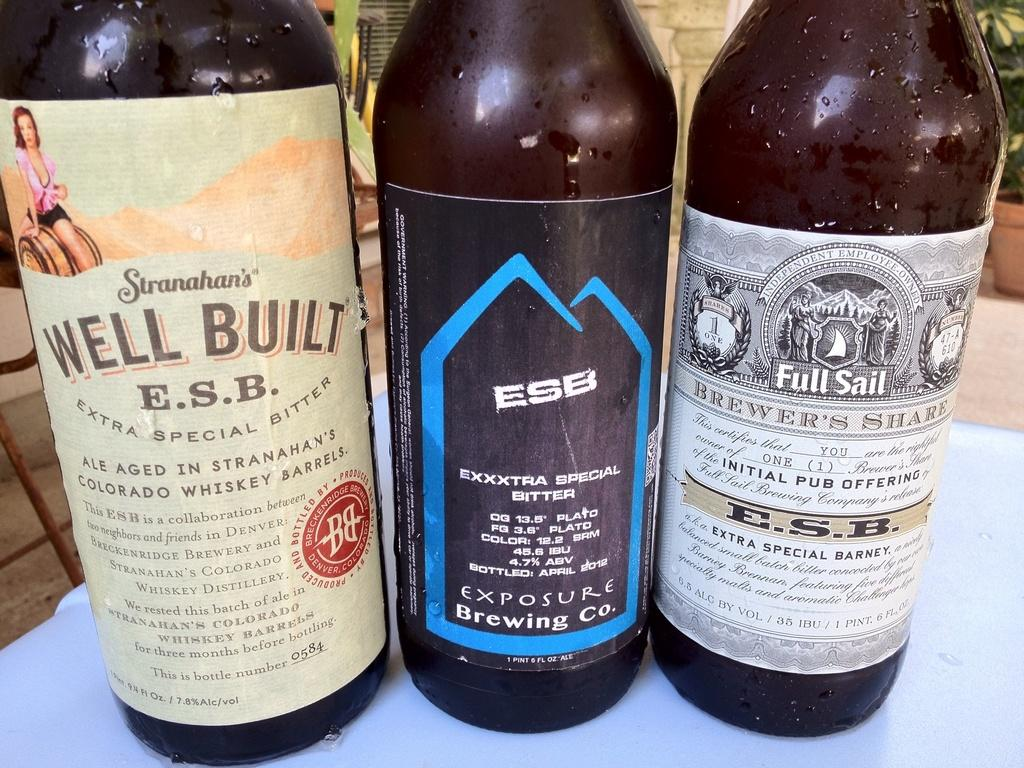<image>
Present a compact description of the photo's key features. Well Built brand bitter ale is next to two other bitter ales from different companies. 